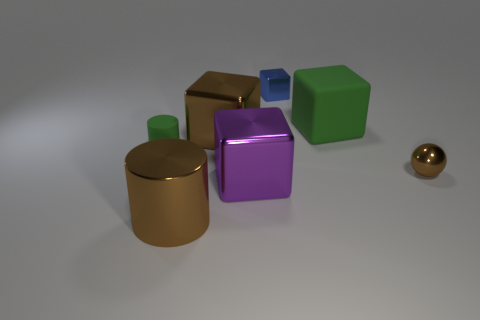Add 1 large shiny blocks. How many objects exist? 8 Subtract all cylinders. How many objects are left? 5 Add 6 big metal blocks. How many big metal blocks exist? 8 Subtract 1 green blocks. How many objects are left? 6 Subtract all big green blocks. Subtract all tiny blue metallic cubes. How many objects are left? 5 Add 2 shiny objects. How many shiny objects are left? 7 